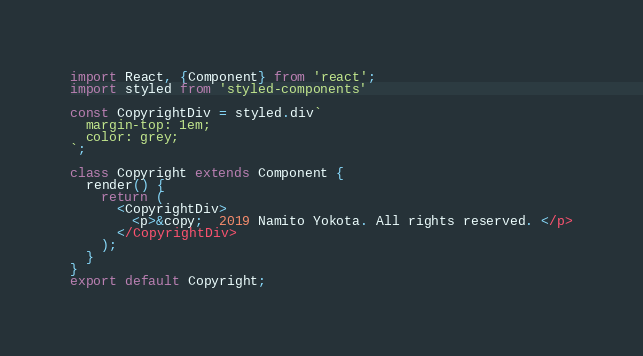<code> <loc_0><loc_0><loc_500><loc_500><_JavaScript_>import React, {Component} from 'react';
import styled from 'styled-components'

const CopyrightDiv = styled.div`
  margin-top: 1em;
  color: grey;
`;

class Copyright extends Component {
  render() {
    return (
      <CopyrightDiv>
        <p>&copy;  2019 Namito Yokota. All rights reserved. </p>
      </CopyrightDiv>
    );
  }
}
export default Copyright;</code> 